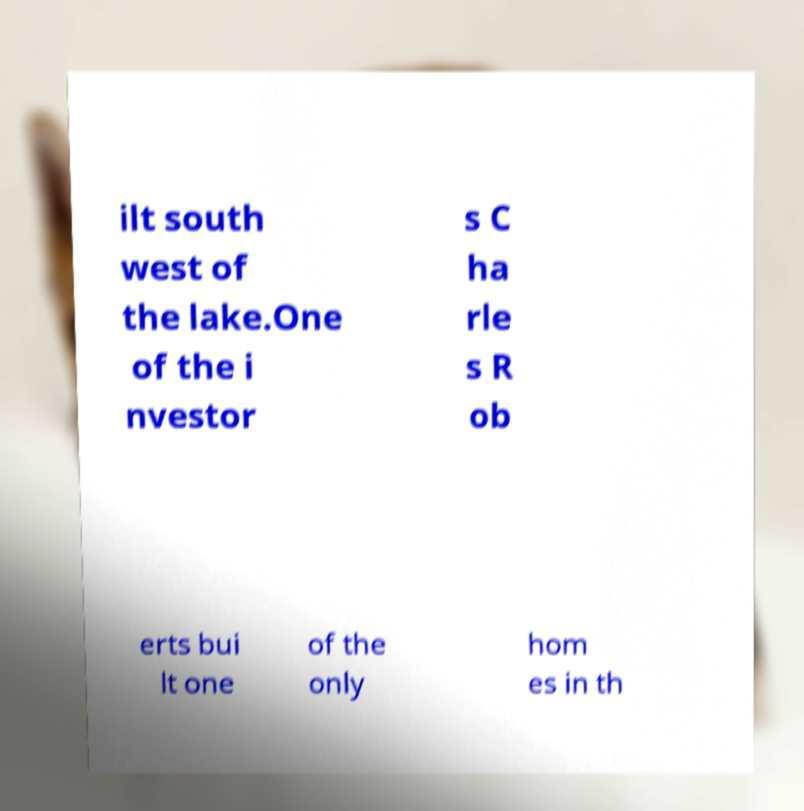For documentation purposes, I need the text within this image transcribed. Could you provide that? ilt south west of the lake.One of the i nvestor s C ha rle s R ob erts bui lt one of the only hom es in th 